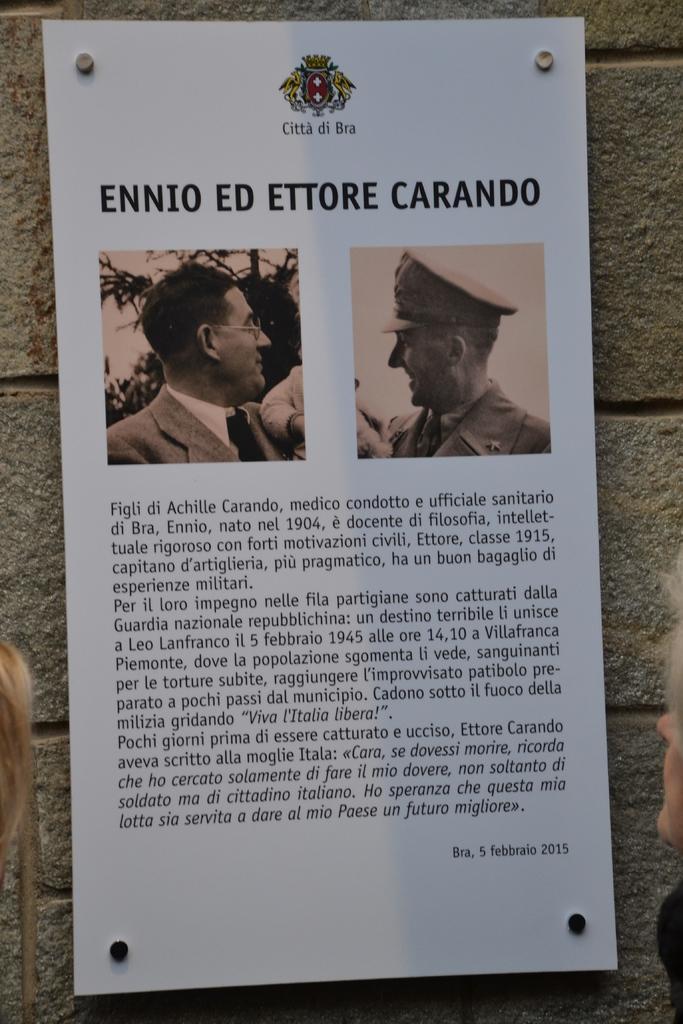How would you summarize this image in a sentence or two? In this image I can see a paper attached to the wall and on the paper I can see a person image , text. 